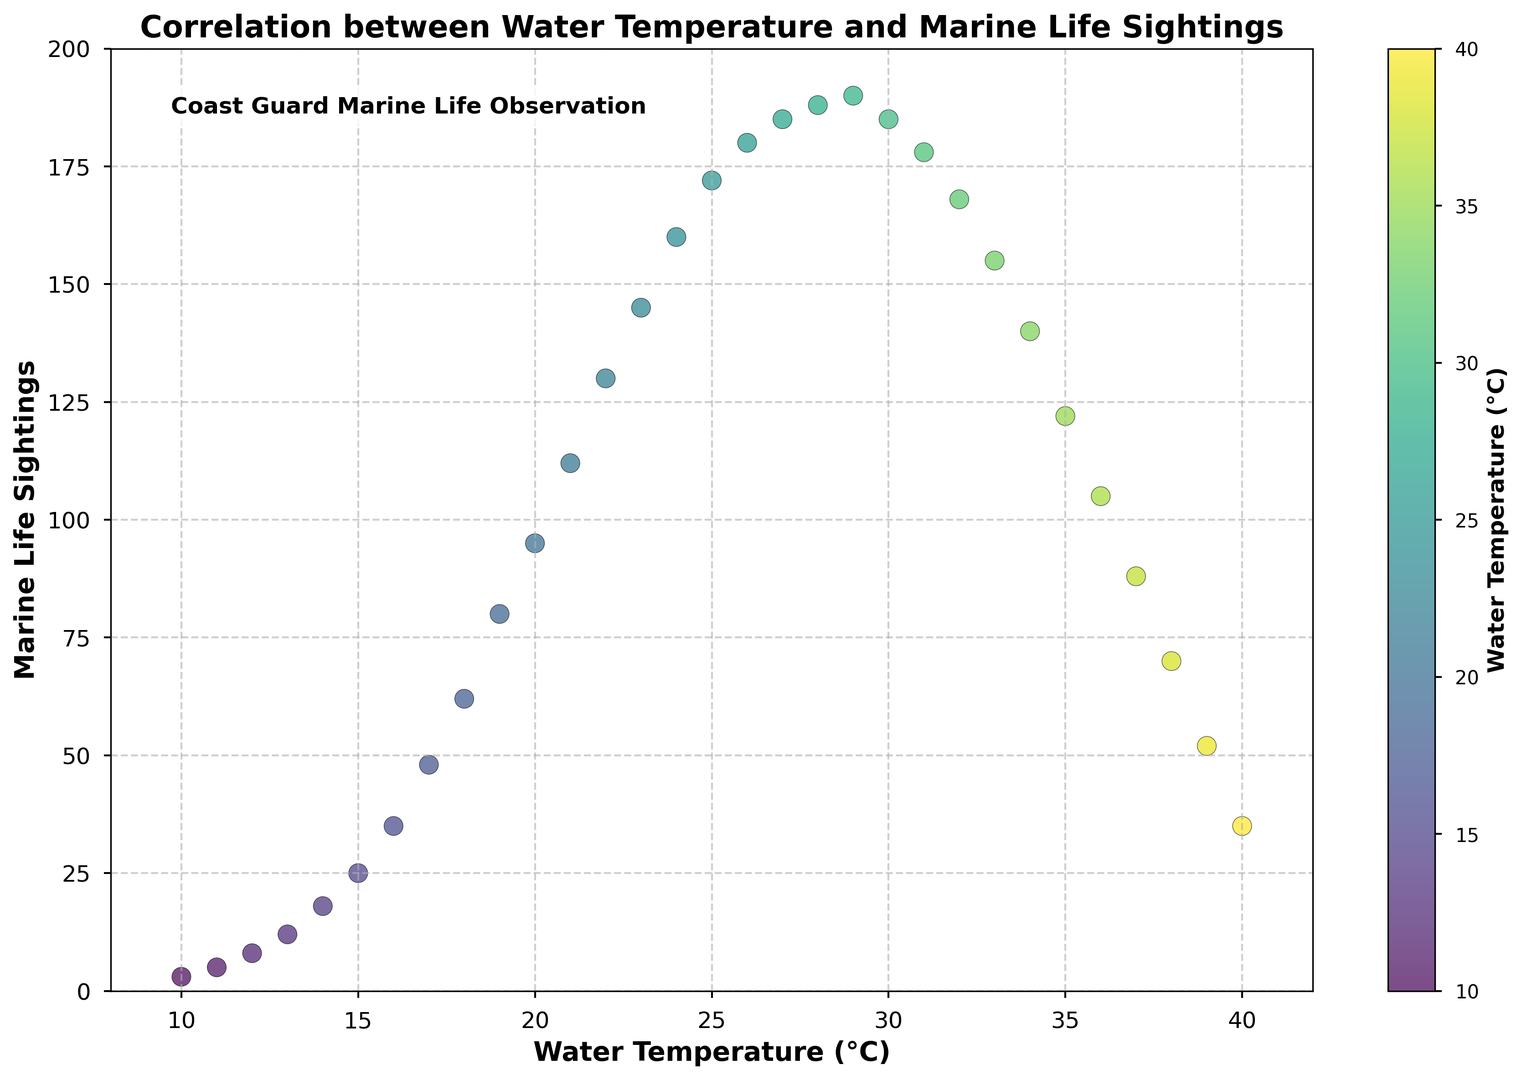What is the range of marine life sightings for water temperatures between 15°C and 20°C? Look at the horizontal axis between 15°C and 20°C and note the corresponding marine life sightings on the vertical axis. The values range from 25 to 95.
Answer: 25 to 95 At which water temperature do marine life sightings peak based on the scatter plot? Observe the point on the scatter plot with the highest vertical position (marine life sightings). The highest number of sightings is observed at 29°C at 190 sightings.
Answer: 29°C How does the number of sightings change as water temperature increases from 30°C to 35°C? Trace the scatter plot from 30°C to 35°C and note the marine life sightings. Sightings decrease from 185 to 122.
Answer: Decreases Which water temperature range shows the most rapid increase in marine life sightings? Look for the steepest increase between data points on the scatter plot. From 19°C to 22°C, marine life sightings sharply increase from 80 to 130.
Answer: 19°C to 22°C What is the correlation trend between water temperature and marine life sightings? Observe the general pattern of the scatter plot points. Marine life sightings increase with water temperature up to 29°C, then decrease as temperature continues to rise beyond 29°C.
Answer: Increases then decreases Compare the number of marine life sightings at 10°C and at 20°C. Which is greater? Locate the points corresponding to 10°C and 20°C on the scatter plot. 10°C has 3 sightings, and 20°C has 95 sightings.
Answer: 20°C What is the average marine life sightings for water temperatures between 10°C and 30°C? Identify the sightings in this range: [3, 5, 8, 12, 18, 25, 35, 48, 62, 80, 95, 112, 130, 145, 160, 172, 180, 185, 188, 190]. Sum these values and divide by the number of data points (20): (1783 / 20) = 89.15.
Answer: 89.15 At which two temperatures are marine life sightings similar, being around 185 sightings? Find points around 185 sightings on the scatter plot. These occur at 29°C (190 sightings) and 26°C (180 sightings).
Answer: 26°C and 29°C How does the scatter plot visually indicate higher water temperatures? Notice the color gradient used in the scatter plot. Higher temperatures are shown in lighter shades closer to the greenish-yellow part of the colormap.
Answer: Lighter shades 